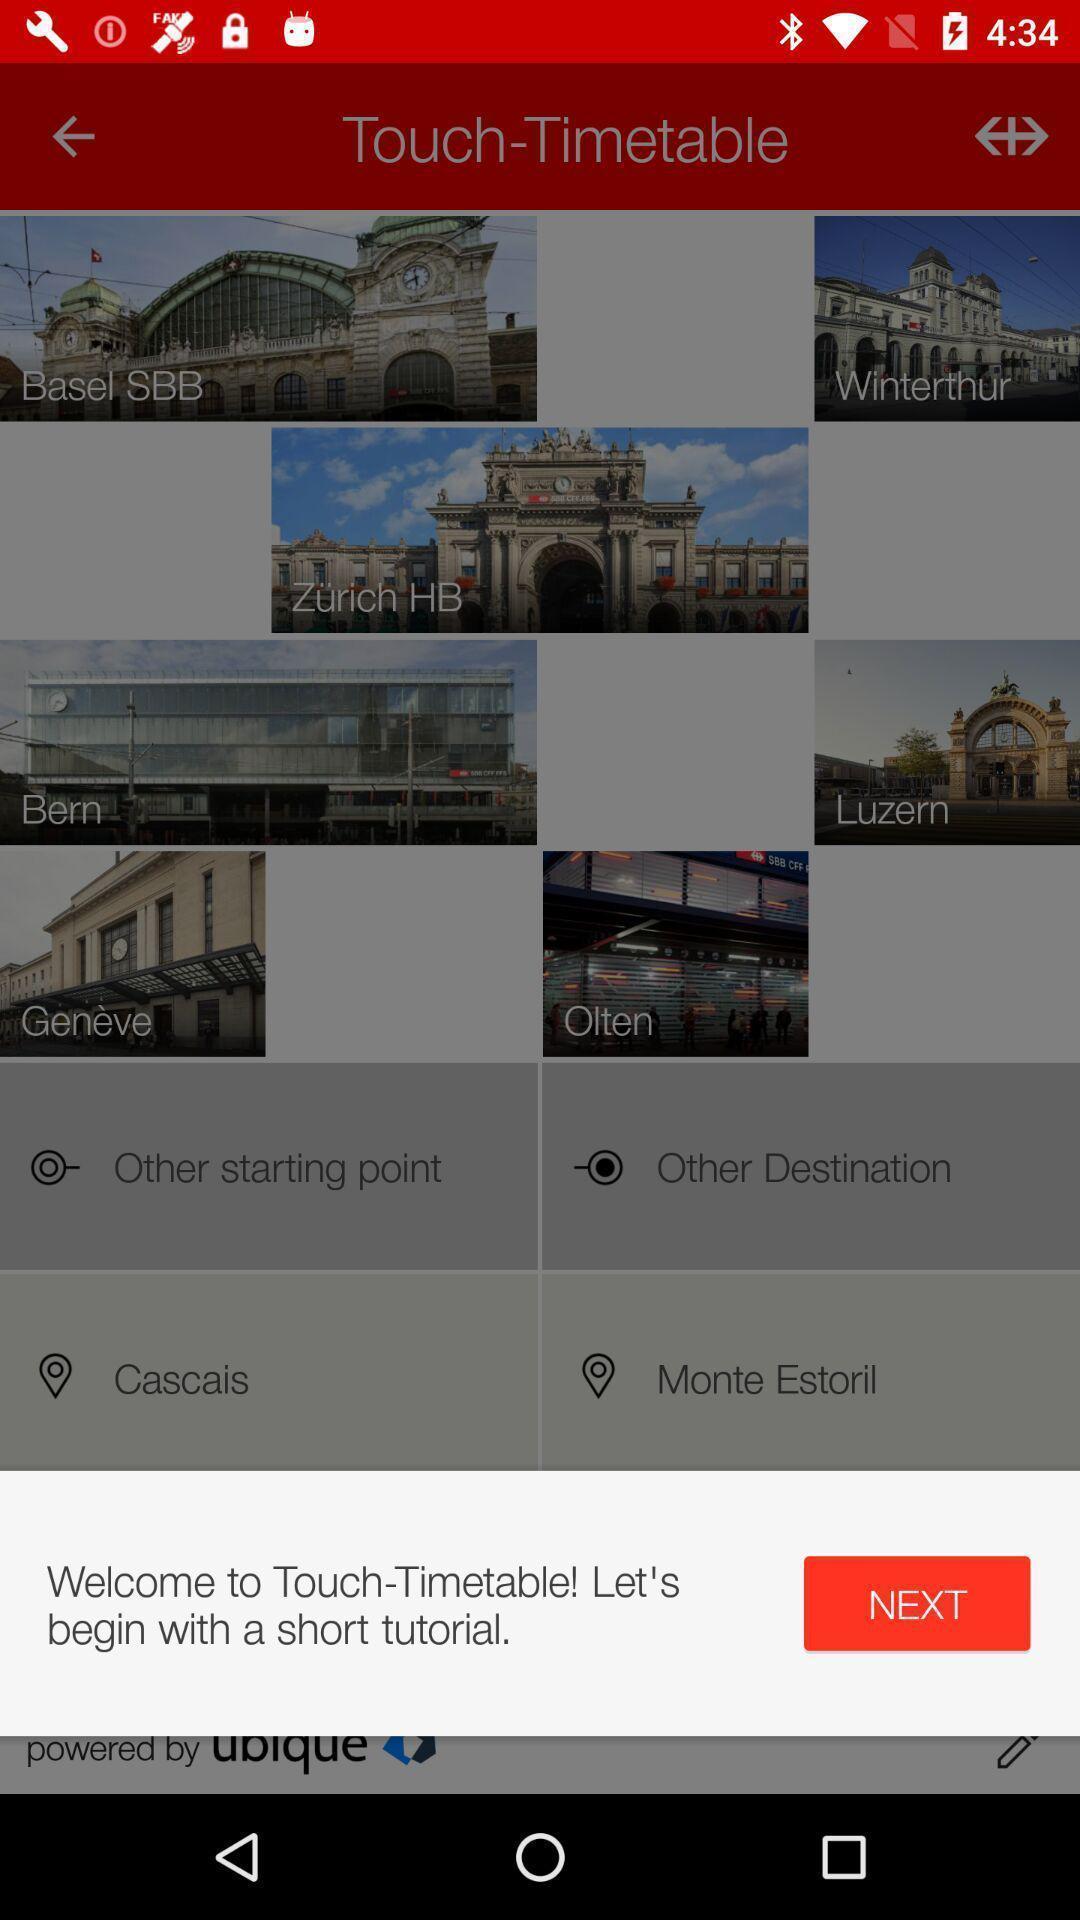Describe this image in words. Welcome page of a travelling app. 